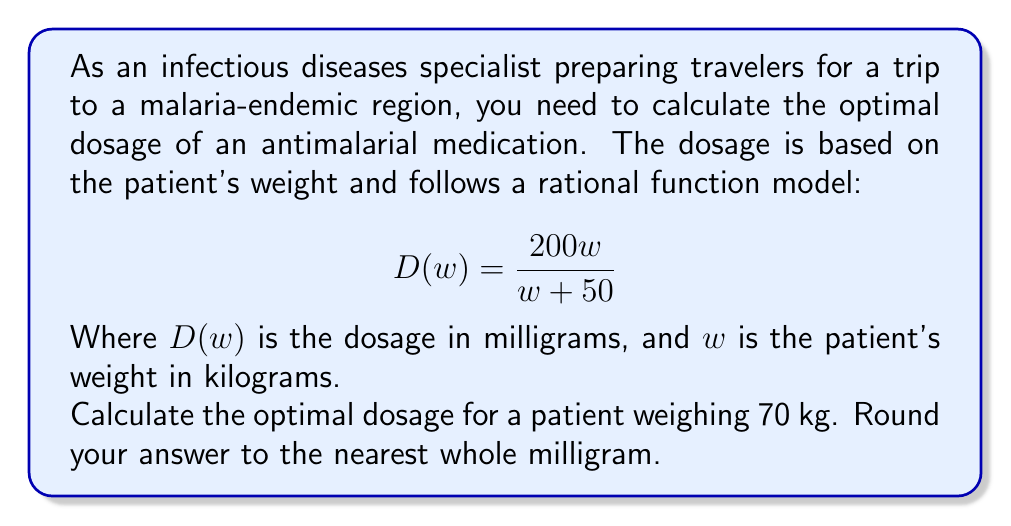Teach me how to tackle this problem. To solve this problem, we'll follow these steps:

1) We have the rational function for the dosage:
   $$D(w) = \frac{200w}{w + 50}$$

2) We need to calculate $D(70)$ since the patient weighs 70 kg:
   $$D(70) = \frac{200(70)}{70 + 50}$$

3) Simplify the numerator:
   $$D(70) = \frac{14000}{70 + 50}$$

4) Simplify the denominator:
   $$D(70) = \frac{14000}{120}$$

5) Divide:
   $$D(70) = 116.6666...$$

6) Round to the nearest whole milligram:
   $$D(70) \approx 117\text{ mg}$$

Therefore, the optimal dosage for a 70 kg patient is 117 mg.
Answer: 117 mg 